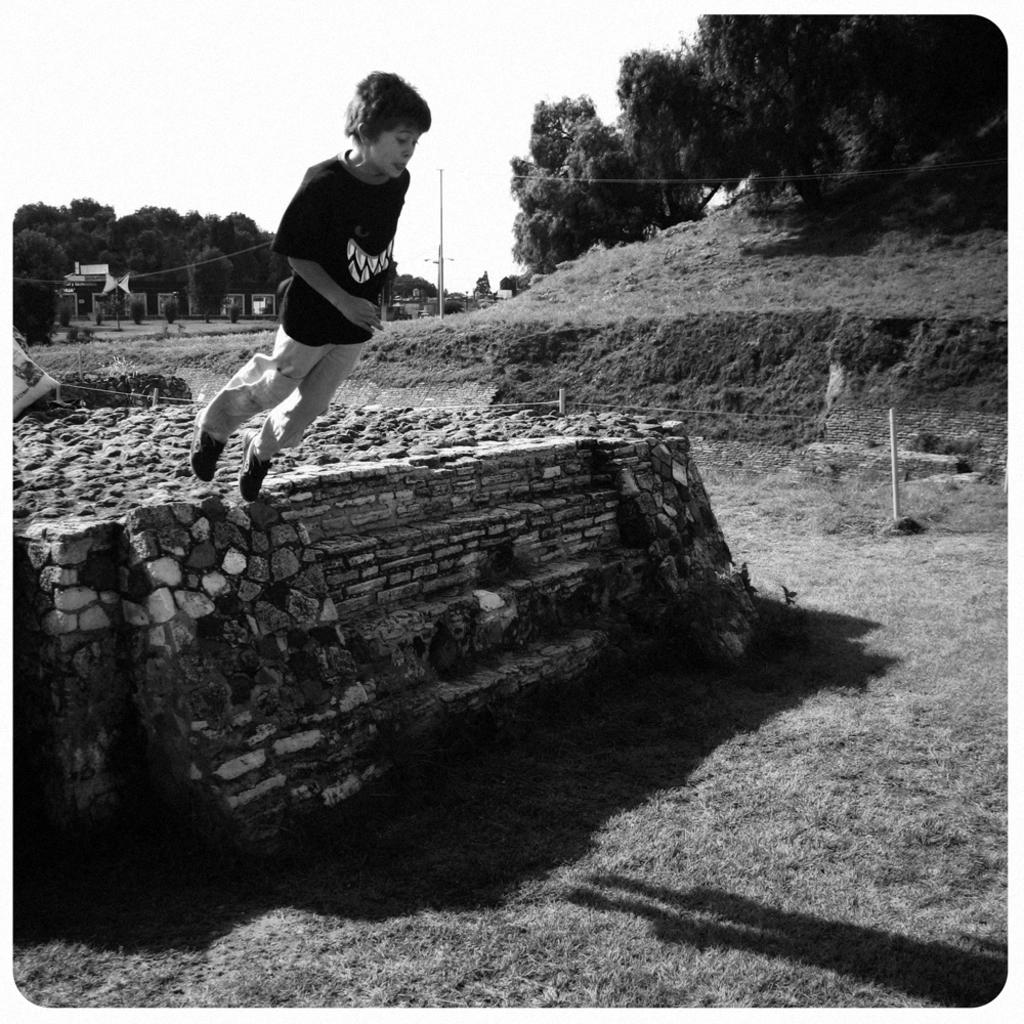What is the color scheme of the image? The image is black and white. What is the person in the image doing? The person is standing on a platform and trying to jump from it. What can be seen in the background of the image? There are trees, poles, grass, buildings, and the sky visible in the background of the image. What type of room is visible in the image? There is no room visible in the image; it is an outdoor scene with a person standing on a platform. What border is present around the image? There is no border visible around the image; we are only discussing the content within the image. 